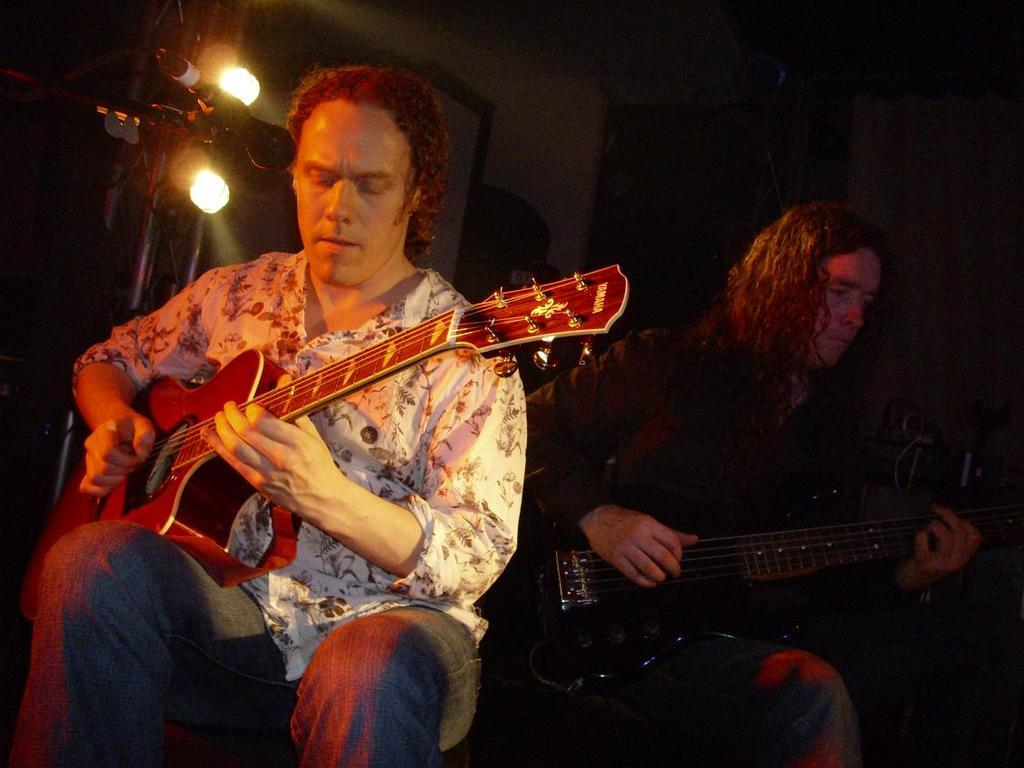How many people are in the image? There are two persons in the image. What are the two persons doing in the image? The two persons are sitting on a chair and playing a guitar. Can you describe the lighting in the image? Yes, there is a light visible in the image. What subject is the teacher teaching in the image? There is no teacher or teaching activity present in the image. What type of work is the laborer performing in the image? There is no laborer or work activity present in the image. 